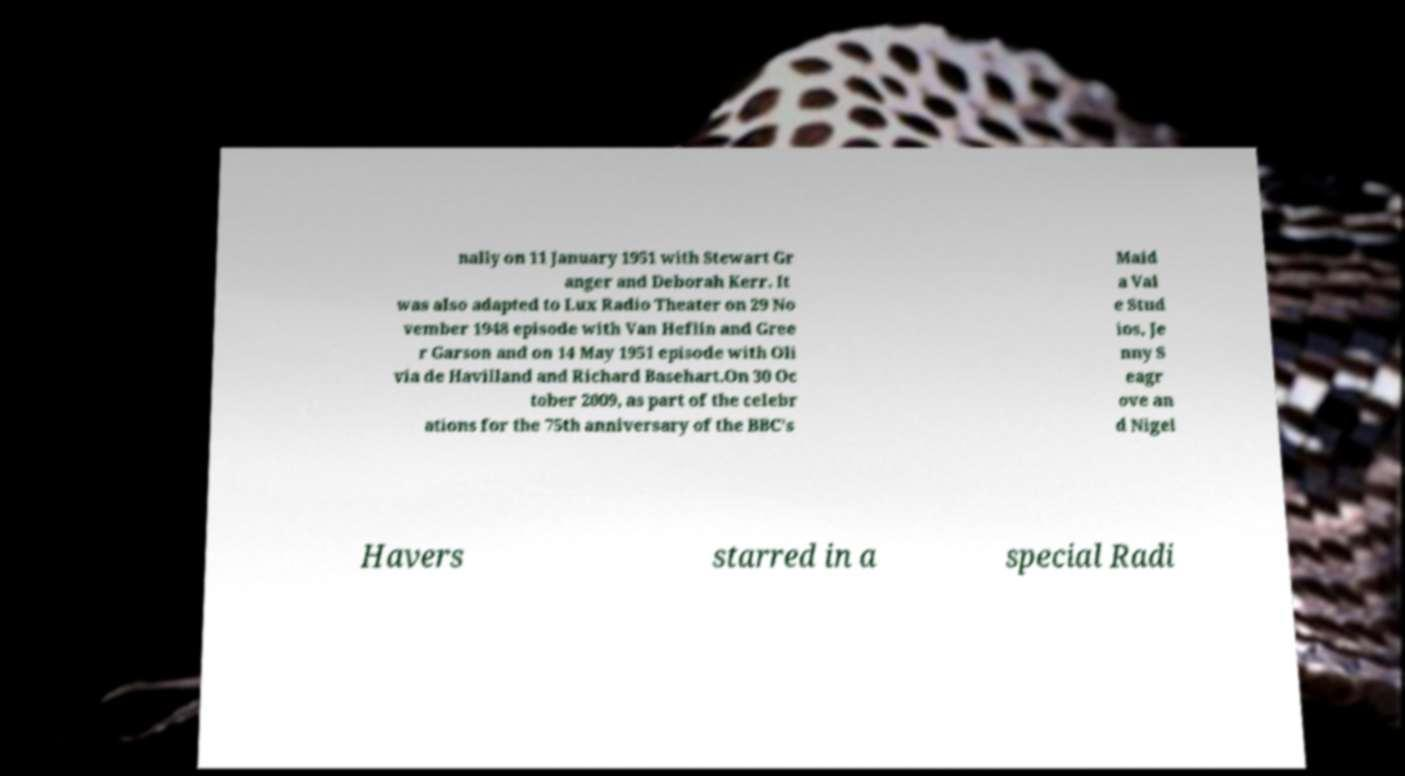Can you read and provide the text displayed in the image?This photo seems to have some interesting text. Can you extract and type it out for me? nally on 11 January 1951 with Stewart Gr anger and Deborah Kerr. It was also adapted to Lux Radio Theater on 29 No vember 1948 episode with Van Heflin and Gree r Garson and on 14 May 1951 episode with Oli via de Havilland and Richard Basehart.On 30 Oc tober 2009, as part of the celebr ations for the 75th anniversary of the BBC's Maid a Val e Stud ios, Je nny S eagr ove an d Nigel Havers starred in a special Radi 